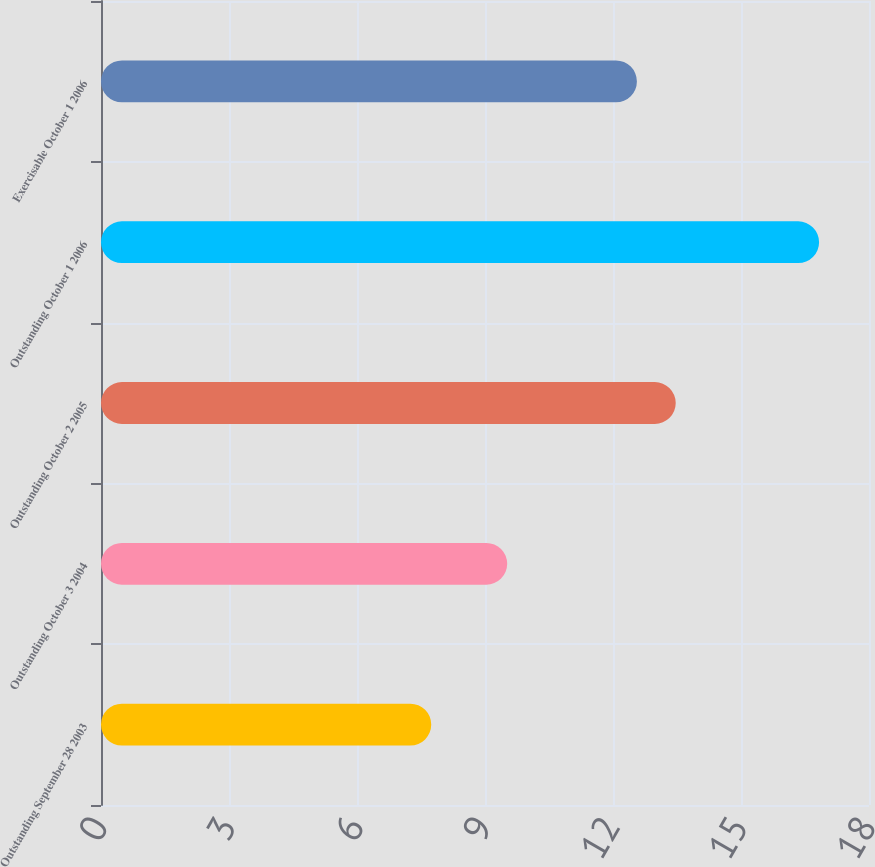Convert chart to OTSL. <chart><loc_0><loc_0><loc_500><loc_500><bar_chart><fcel>Outstanding September 28 2003<fcel>Outstanding October 3 2004<fcel>Outstanding October 2 2005<fcel>Outstanding October 1 2006<fcel>Exercisable October 1 2006<nl><fcel>7.74<fcel>9.52<fcel>13.47<fcel>16.83<fcel>12.56<nl></chart> 